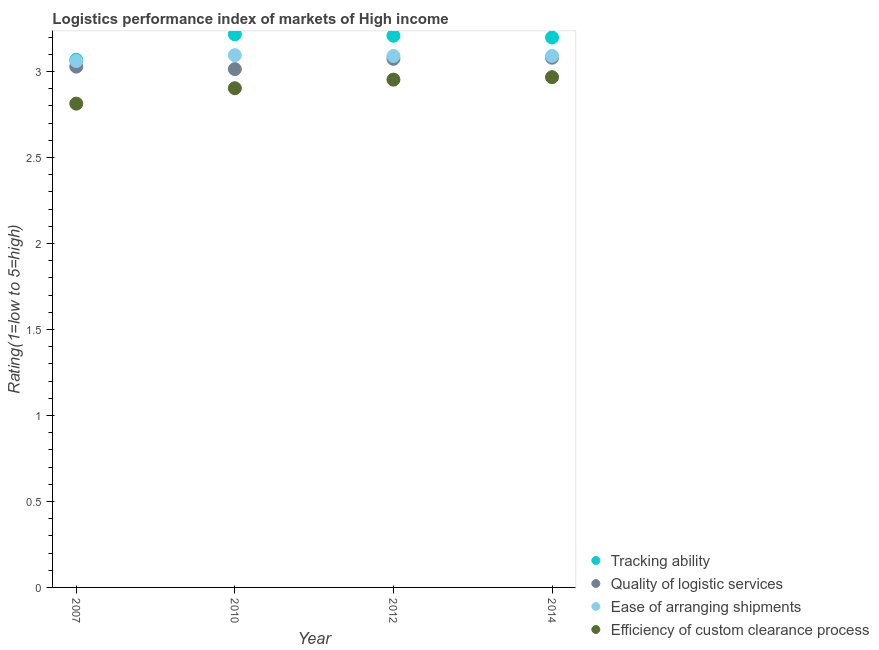How many different coloured dotlines are there?
Keep it short and to the point. 4. What is the lpi rating of efficiency of custom clearance process in 2007?
Ensure brevity in your answer.  2.81. Across all years, what is the maximum lpi rating of ease of arranging shipments?
Offer a very short reply. 3.1. Across all years, what is the minimum lpi rating of efficiency of custom clearance process?
Your answer should be very brief. 2.81. What is the total lpi rating of tracking ability in the graph?
Provide a succinct answer. 12.69. What is the difference between the lpi rating of tracking ability in 2007 and that in 2014?
Keep it short and to the point. -0.13. What is the difference between the lpi rating of ease of arranging shipments in 2007 and the lpi rating of tracking ability in 2014?
Provide a short and direct response. -0.14. What is the average lpi rating of quality of logistic services per year?
Ensure brevity in your answer.  3.05. In the year 2014, what is the difference between the lpi rating of ease of arranging shipments and lpi rating of efficiency of custom clearance process?
Offer a terse response. 0.12. What is the ratio of the lpi rating of tracking ability in 2007 to that in 2012?
Provide a succinct answer. 0.96. Is the lpi rating of ease of arranging shipments in 2010 less than that in 2014?
Your answer should be very brief. No. Is the difference between the lpi rating of efficiency of custom clearance process in 2007 and 2014 greater than the difference between the lpi rating of ease of arranging shipments in 2007 and 2014?
Your answer should be compact. No. What is the difference between the highest and the second highest lpi rating of quality of logistic services?
Give a very brief answer. 0.01. What is the difference between the highest and the lowest lpi rating of ease of arranging shipments?
Keep it short and to the point. 0.03. Is it the case that in every year, the sum of the lpi rating of tracking ability and lpi rating of efficiency of custom clearance process is greater than the sum of lpi rating of quality of logistic services and lpi rating of ease of arranging shipments?
Provide a short and direct response. No. Is the lpi rating of efficiency of custom clearance process strictly greater than the lpi rating of ease of arranging shipments over the years?
Make the answer very short. No. How many dotlines are there?
Provide a short and direct response. 4. Does the graph contain grids?
Give a very brief answer. No. What is the title of the graph?
Keep it short and to the point. Logistics performance index of markets of High income. What is the label or title of the X-axis?
Your answer should be very brief. Year. What is the label or title of the Y-axis?
Your response must be concise. Rating(1=low to 5=high). What is the Rating(1=low to 5=high) of Tracking ability in 2007?
Provide a short and direct response. 3.07. What is the Rating(1=low to 5=high) of Quality of logistic services in 2007?
Provide a short and direct response. 3.03. What is the Rating(1=low to 5=high) of Ease of arranging shipments in 2007?
Make the answer very short. 3.06. What is the Rating(1=low to 5=high) of Efficiency of custom clearance process in 2007?
Make the answer very short. 2.81. What is the Rating(1=low to 5=high) of Tracking ability in 2010?
Provide a succinct answer. 3.22. What is the Rating(1=low to 5=high) in Quality of logistic services in 2010?
Give a very brief answer. 3.01. What is the Rating(1=low to 5=high) in Ease of arranging shipments in 2010?
Give a very brief answer. 3.1. What is the Rating(1=low to 5=high) in Efficiency of custom clearance process in 2010?
Provide a short and direct response. 2.9. What is the Rating(1=low to 5=high) in Tracking ability in 2012?
Make the answer very short. 3.21. What is the Rating(1=low to 5=high) of Quality of logistic services in 2012?
Make the answer very short. 3.07. What is the Rating(1=low to 5=high) in Ease of arranging shipments in 2012?
Offer a very short reply. 3.09. What is the Rating(1=low to 5=high) in Efficiency of custom clearance process in 2012?
Provide a short and direct response. 2.95. What is the Rating(1=low to 5=high) in Tracking ability in 2014?
Keep it short and to the point. 3.2. What is the Rating(1=low to 5=high) in Quality of logistic services in 2014?
Make the answer very short. 3.08. What is the Rating(1=low to 5=high) in Ease of arranging shipments in 2014?
Keep it short and to the point. 3.09. What is the Rating(1=low to 5=high) of Efficiency of custom clearance process in 2014?
Offer a terse response. 2.97. Across all years, what is the maximum Rating(1=low to 5=high) of Tracking ability?
Your answer should be compact. 3.22. Across all years, what is the maximum Rating(1=low to 5=high) in Quality of logistic services?
Your answer should be compact. 3.08. Across all years, what is the maximum Rating(1=low to 5=high) of Ease of arranging shipments?
Provide a succinct answer. 3.1. Across all years, what is the maximum Rating(1=low to 5=high) in Efficiency of custom clearance process?
Offer a terse response. 2.97. Across all years, what is the minimum Rating(1=low to 5=high) in Tracking ability?
Provide a succinct answer. 3.07. Across all years, what is the minimum Rating(1=low to 5=high) in Quality of logistic services?
Offer a terse response. 3.01. Across all years, what is the minimum Rating(1=low to 5=high) of Ease of arranging shipments?
Make the answer very short. 3.06. Across all years, what is the minimum Rating(1=low to 5=high) of Efficiency of custom clearance process?
Provide a short and direct response. 2.81. What is the total Rating(1=low to 5=high) in Tracking ability in the graph?
Your response must be concise. 12.69. What is the total Rating(1=low to 5=high) of Quality of logistic services in the graph?
Give a very brief answer. 12.2. What is the total Rating(1=low to 5=high) in Ease of arranging shipments in the graph?
Offer a very short reply. 12.34. What is the total Rating(1=low to 5=high) of Efficiency of custom clearance process in the graph?
Your answer should be very brief. 11.64. What is the difference between the Rating(1=low to 5=high) in Tracking ability in 2007 and that in 2010?
Your response must be concise. -0.15. What is the difference between the Rating(1=low to 5=high) of Quality of logistic services in 2007 and that in 2010?
Offer a very short reply. 0.01. What is the difference between the Rating(1=low to 5=high) of Ease of arranging shipments in 2007 and that in 2010?
Your answer should be very brief. -0.03. What is the difference between the Rating(1=low to 5=high) in Efficiency of custom clearance process in 2007 and that in 2010?
Offer a very short reply. -0.09. What is the difference between the Rating(1=low to 5=high) of Tracking ability in 2007 and that in 2012?
Provide a succinct answer. -0.14. What is the difference between the Rating(1=low to 5=high) in Quality of logistic services in 2007 and that in 2012?
Give a very brief answer. -0.05. What is the difference between the Rating(1=low to 5=high) in Ease of arranging shipments in 2007 and that in 2012?
Ensure brevity in your answer.  -0.03. What is the difference between the Rating(1=low to 5=high) in Efficiency of custom clearance process in 2007 and that in 2012?
Provide a short and direct response. -0.14. What is the difference between the Rating(1=low to 5=high) in Tracking ability in 2007 and that in 2014?
Offer a very short reply. -0.13. What is the difference between the Rating(1=low to 5=high) of Quality of logistic services in 2007 and that in 2014?
Offer a terse response. -0.05. What is the difference between the Rating(1=low to 5=high) in Ease of arranging shipments in 2007 and that in 2014?
Offer a terse response. -0.03. What is the difference between the Rating(1=low to 5=high) in Efficiency of custom clearance process in 2007 and that in 2014?
Keep it short and to the point. -0.15. What is the difference between the Rating(1=low to 5=high) in Tracking ability in 2010 and that in 2012?
Your answer should be compact. 0.01. What is the difference between the Rating(1=low to 5=high) in Quality of logistic services in 2010 and that in 2012?
Keep it short and to the point. -0.06. What is the difference between the Rating(1=low to 5=high) of Ease of arranging shipments in 2010 and that in 2012?
Offer a terse response. 0. What is the difference between the Rating(1=low to 5=high) in Efficiency of custom clearance process in 2010 and that in 2012?
Your answer should be compact. -0.05. What is the difference between the Rating(1=low to 5=high) in Tracking ability in 2010 and that in 2014?
Keep it short and to the point. 0.02. What is the difference between the Rating(1=low to 5=high) of Quality of logistic services in 2010 and that in 2014?
Ensure brevity in your answer.  -0.07. What is the difference between the Rating(1=low to 5=high) of Ease of arranging shipments in 2010 and that in 2014?
Ensure brevity in your answer.  0. What is the difference between the Rating(1=low to 5=high) of Efficiency of custom clearance process in 2010 and that in 2014?
Make the answer very short. -0.06. What is the difference between the Rating(1=low to 5=high) in Tracking ability in 2012 and that in 2014?
Offer a terse response. 0.01. What is the difference between the Rating(1=low to 5=high) of Quality of logistic services in 2012 and that in 2014?
Offer a terse response. -0.01. What is the difference between the Rating(1=low to 5=high) in Ease of arranging shipments in 2012 and that in 2014?
Offer a very short reply. -0. What is the difference between the Rating(1=low to 5=high) of Efficiency of custom clearance process in 2012 and that in 2014?
Keep it short and to the point. -0.01. What is the difference between the Rating(1=low to 5=high) of Tracking ability in 2007 and the Rating(1=low to 5=high) of Quality of logistic services in 2010?
Provide a succinct answer. 0.05. What is the difference between the Rating(1=low to 5=high) in Tracking ability in 2007 and the Rating(1=low to 5=high) in Ease of arranging shipments in 2010?
Offer a very short reply. -0.03. What is the difference between the Rating(1=low to 5=high) in Tracking ability in 2007 and the Rating(1=low to 5=high) in Efficiency of custom clearance process in 2010?
Offer a terse response. 0.17. What is the difference between the Rating(1=low to 5=high) of Quality of logistic services in 2007 and the Rating(1=low to 5=high) of Ease of arranging shipments in 2010?
Provide a short and direct response. -0.07. What is the difference between the Rating(1=low to 5=high) of Quality of logistic services in 2007 and the Rating(1=low to 5=high) of Efficiency of custom clearance process in 2010?
Keep it short and to the point. 0.13. What is the difference between the Rating(1=low to 5=high) in Ease of arranging shipments in 2007 and the Rating(1=low to 5=high) in Efficiency of custom clearance process in 2010?
Provide a short and direct response. 0.16. What is the difference between the Rating(1=low to 5=high) in Tracking ability in 2007 and the Rating(1=low to 5=high) in Quality of logistic services in 2012?
Provide a succinct answer. -0.01. What is the difference between the Rating(1=low to 5=high) in Tracking ability in 2007 and the Rating(1=low to 5=high) in Ease of arranging shipments in 2012?
Make the answer very short. -0.02. What is the difference between the Rating(1=low to 5=high) in Tracking ability in 2007 and the Rating(1=low to 5=high) in Efficiency of custom clearance process in 2012?
Provide a succinct answer. 0.12. What is the difference between the Rating(1=low to 5=high) in Quality of logistic services in 2007 and the Rating(1=low to 5=high) in Ease of arranging shipments in 2012?
Provide a succinct answer. -0.06. What is the difference between the Rating(1=low to 5=high) in Quality of logistic services in 2007 and the Rating(1=low to 5=high) in Efficiency of custom clearance process in 2012?
Give a very brief answer. 0.08. What is the difference between the Rating(1=low to 5=high) in Ease of arranging shipments in 2007 and the Rating(1=low to 5=high) in Efficiency of custom clearance process in 2012?
Keep it short and to the point. 0.11. What is the difference between the Rating(1=low to 5=high) in Tracking ability in 2007 and the Rating(1=low to 5=high) in Quality of logistic services in 2014?
Offer a very short reply. -0.01. What is the difference between the Rating(1=low to 5=high) in Tracking ability in 2007 and the Rating(1=low to 5=high) in Ease of arranging shipments in 2014?
Keep it short and to the point. -0.02. What is the difference between the Rating(1=low to 5=high) in Tracking ability in 2007 and the Rating(1=low to 5=high) in Efficiency of custom clearance process in 2014?
Give a very brief answer. 0.1. What is the difference between the Rating(1=low to 5=high) of Quality of logistic services in 2007 and the Rating(1=low to 5=high) of Ease of arranging shipments in 2014?
Your answer should be very brief. -0.06. What is the difference between the Rating(1=low to 5=high) of Quality of logistic services in 2007 and the Rating(1=low to 5=high) of Efficiency of custom clearance process in 2014?
Your response must be concise. 0.06. What is the difference between the Rating(1=low to 5=high) of Ease of arranging shipments in 2007 and the Rating(1=low to 5=high) of Efficiency of custom clearance process in 2014?
Your answer should be very brief. 0.09. What is the difference between the Rating(1=low to 5=high) of Tracking ability in 2010 and the Rating(1=low to 5=high) of Quality of logistic services in 2012?
Keep it short and to the point. 0.14. What is the difference between the Rating(1=low to 5=high) of Tracking ability in 2010 and the Rating(1=low to 5=high) of Ease of arranging shipments in 2012?
Your answer should be compact. 0.13. What is the difference between the Rating(1=low to 5=high) of Tracking ability in 2010 and the Rating(1=low to 5=high) of Efficiency of custom clearance process in 2012?
Make the answer very short. 0.26. What is the difference between the Rating(1=low to 5=high) of Quality of logistic services in 2010 and the Rating(1=low to 5=high) of Ease of arranging shipments in 2012?
Offer a terse response. -0.08. What is the difference between the Rating(1=low to 5=high) of Quality of logistic services in 2010 and the Rating(1=low to 5=high) of Efficiency of custom clearance process in 2012?
Provide a succinct answer. 0.06. What is the difference between the Rating(1=low to 5=high) of Ease of arranging shipments in 2010 and the Rating(1=low to 5=high) of Efficiency of custom clearance process in 2012?
Keep it short and to the point. 0.14. What is the difference between the Rating(1=low to 5=high) of Tracking ability in 2010 and the Rating(1=low to 5=high) of Quality of logistic services in 2014?
Provide a succinct answer. 0.14. What is the difference between the Rating(1=low to 5=high) of Tracking ability in 2010 and the Rating(1=low to 5=high) of Ease of arranging shipments in 2014?
Ensure brevity in your answer.  0.13. What is the difference between the Rating(1=low to 5=high) of Tracking ability in 2010 and the Rating(1=low to 5=high) of Efficiency of custom clearance process in 2014?
Make the answer very short. 0.25. What is the difference between the Rating(1=low to 5=high) in Quality of logistic services in 2010 and the Rating(1=low to 5=high) in Ease of arranging shipments in 2014?
Provide a succinct answer. -0.08. What is the difference between the Rating(1=low to 5=high) of Quality of logistic services in 2010 and the Rating(1=low to 5=high) of Efficiency of custom clearance process in 2014?
Your response must be concise. 0.05. What is the difference between the Rating(1=low to 5=high) in Ease of arranging shipments in 2010 and the Rating(1=low to 5=high) in Efficiency of custom clearance process in 2014?
Offer a terse response. 0.13. What is the difference between the Rating(1=low to 5=high) in Tracking ability in 2012 and the Rating(1=low to 5=high) in Quality of logistic services in 2014?
Ensure brevity in your answer.  0.13. What is the difference between the Rating(1=low to 5=high) of Tracking ability in 2012 and the Rating(1=low to 5=high) of Ease of arranging shipments in 2014?
Offer a very short reply. 0.12. What is the difference between the Rating(1=low to 5=high) of Tracking ability in 2012 and the Rating(1=low to 5=high) of Efficiency of custom clearance process in 2014?
Make the answer very short. 0.24. What is the difference between the Rating(1=low to 5=high) of Quality of logistic services in 2012 and the Rating(1=low to 5=high) of Ease of arranging shipments in 2014?
Your answer should be very brief. -0.02. What is the difference between the Rating(1=low to 5=high) of Quality of logistic services in 2012 and the Rating(1=low to 5=high) of Efficiency of custom clearance process in 2014?
Offer a very short reply. 0.11. What is the difference between the Rating(1=low to 5=high) in Ease of arranging shipments in 2012 and the Rating(1=low to 5=high) in Efficiency of custom clearance process in 2014?
Offer a very short reply. 0.12. What is the average Rating(1=low to 5=high) in Tracking ability per year?
Offer a very short reply. 3.17. What is the average Rating(1=low to 5=high) in Quality of logistic services per year?
Make the answer very short. 3.05. What is the average Rating(1=low to 5=high) of Ease of arranging shipments per year?
Make the answer very short. 3.08. What is the average Rating(1=low to 5=high) in Efficiency of custom clearance process per year?
Your answer should be compact. 2.91. In the year 2007, what is the difference between the Rating(1=low to 5=high) in Tracking ability and Rating(1=low to 5=high) in Quality of logistic services?
Ensure brevity in your answer.  0.04. In the year 2007, what is the difference between the Rating(1=low to 5=high) in Tracking ability and Rating(1=low to 5=high) in Ease of arranging shipments?
Provide a short and direct response. 0.01. In the year 2007, what is the difference between the Rating(1=low to 5=high) in Tracking ability and Rating(1=low to 5=high) in Efficiency of custom clearance process?
Provide a short and direct response. 0.25. In the year 2007, what is the difference between the Rating(1=low to 5=high) of Quality of logistic services and Rating(1=low to 5=high) of Ease of arranging shipments?
Offer a terse response. -0.03. In the year 2007, what is the difference between the Rating(1=low to 5=high) of Quality of logistic services and Rating(1=low to 5=high) of Efficiency of custom clearance process?
Your answer should be compact. 0.22. In the year 2007, what is the difference between the Rating(1=low to 5=high) of Ease of arranging shipments and Rating(1=low to 5=high) of Efficiency of custom clearance process?
Provide a succinct answer. 0.25. In the year 2010, what is the difference between the Rating(1=low to 5=high) of Tracking ability and Rating(1=low to 5=high) of Quality of logistic services?
Provide a short and direct response. 0.2. In the year 2010, what is the difference between the Rating(1=low to 5=high) in Tracking ability and Rating(1=low to 5=high) in Ease of arranging shipments?
Provide a short and direct response. 0.12. In the year 2010, what is the difference between the Rating(1=low to 5=high) in Tracking ability and Rating(1=low to 5=high) in Efficiency of custom clearance process?
Offer a very short reply. 0.31. In the year 2010, what is the difference between the Rating(1=low to 5=high) of Quality of logistic services and Rating(1=low to 5=high) of Ease of arranging shipments?
Offer a terse response. -0.08. In the year 2010, what is the difference between the Rating(1=low to 5=high) in Ease of arranging shipments and Rating(1=low to 5=high) in Efficiency of custom clearance process?
Keep it short and to the point. 0.19. In the year 2012, what is the difference between the Rating(1=low to 5=high) of Tracking ability and Rating(1=low to 5=high) of Quality of logistic services?
Keep it short and to the point. 0.13. In the year 2012, what is the difference between the Rating(1=low to 5=high) in Tracking ability and Rating(1=low to 5=high) in Ease of arranging shipments?
Your answer should be compact. 0.12. In the year 2012, what is the difference between the Rating(1=low to 5=high) in Tracking ability and Rating(1=low to 5=high) in Efficiency of custom clearance process?
Your answer should be very brief. 0.26. In the year 2012, what is the difference between the Rating(1=low to 5=high) in Quality of logistic services and Rating(1=low to 5=high) in Ease of arranging shipments?
Keep it short and to the point. -0.02. In the year 2012, what is the difference between the Rating(1=low to 5=high) of Quality of logistic services and Rating(1=low to 5=high) of Efficiency of custom clearance process?
Offer a very short reply. 0.12. In the year 2012, what is the difference between the Rating(1=low to 5=high) of Ease of arranging shipments and Rating(1=low to 5=high) of Efficiency of custom clearance process?
Offer a very short reply. 0.14. In the year 2014, what is the difference between the Rating(1=low to 5=high) in Tracking ability and Rating(1=low to 5=high) in Quality of logistic services?
Offer a very short reply. 0.12. In the year 2014, what is the difference between the Rating(1=low to 5=high) of Tracking ability and Rating(1=low to 5=high) of Ease of arranging shipments?
Keep it short and to the point. 0.11. In the year 2014, what is the difference between the Rating(1=low to 5=high) in Tracking ability and Rating(1=low to 5=high) in Efficiency of custom clearance process?
Give a very brief answer. 0.23. In the year 2014, what is the difference between the Rating(1=low to 5=high) of Quality of logistic services and Rating(1=low to 5=high) of Ease of arranging shipments?
Offer a terse response. -0.01. In the year 2014, what is the difference between the Rating(1=low to 5=high) of Quality of logistic services and Rating(1=low to 5=high) of Efficiency of custom clearance process?
Ensure brevity in your answer.  0.11. In the year 2014, what is the difference between the Rating(1=low to 5=high) of Ease of arranging shipments and Rating(1=low to 5=high) of Efficiency of custom clearance process?
Ensure brevity in your answer.  0.12. What is the ratio of the Rating(1=low to 5=high) of Tracking ability in 2007 to that in 2010?
Provide a short and direct response. 0.95. What is the ratio of the Rating(1=low to 5=high) in Ease of arranging shipments in 2007 to that in 2010?
Make the answer very short. 0.99. What is the ratio of the Rating(1=low to 5=high) in Efficiency of custom clearance process in 2007 to that in 2010?
Make the answer very short. 0.97. What is the ratio of the Rating(1=low to 5=high) in Tracking ability in 2007 to that in 2012?
Offer a very short reply. 0.96. What is the ratio of the Rating(1=low to 5=high) in Quality of logistic services in 2007 to that in 2012?
Your response must be concise. 0.99. What is the ratio of the Rating(1=low to 5=high) of Ease of arranging shipments in 2007 to that in 2012?
Provide a succinct answer. 0.99. What is the ratio of the Rating(1=low to 5=high) in Efficiency of custom clearance process in 2007 to that in 2012?
Ensure brevity in your answer.  0.95. What is the ratio of the Rating(1=low to 5=high) of Tracking ability in 2007 to that in 2014?
Make the answer very short. 0.96. What is the ratio of the Rating(1=low to 5=high) in Quality of logistic services in 2007 to that in 2014?
Offer a very short reply. 0.98. What is the ratio of the Rating(1=low to 5=high) in Ease of arranging shipments in 2007 to that in 2014?
Your answer should be compact. 0.99. What is the ratio of the Rating(1=low to 5=high) in Efficiency of custom clearance process in 2007 to that in 2014?
Provide a succinct answer. 0.95. What is the ratio of the Rating(1=low to 5=high) in Quality of logistic services in 2010 to that in 2012?
Provide a succinct answer. 0.98. What is the ratio of the Rating(1=low to 5=high) in Ease of arranging shipments in 2010 to that in 2012?
Ensure brevity in your answer.  1. What is the ratio of the Rating(1=low to 5=high) in Efficiency of custom clearance process in 2010 to that in 2012?
Provide a short and direct response. 0.98. What is the ratio of the Rating(1=low to 5=high) of Tracking ability in 2010 to that in 2014?
Offer a terse response. 1.01. What is the ratio of the Rating(1=low to 5=high) in Quality of logistic services in 2010 to that in 2014?
Ensure brevity in your answer.  0.98. What is the ratio of the Rating(1=low to 5=high) in Efficiency of custom clearance process in 2010 to that in 2014?
Provide a short and direct response. 0.98. What is the difference between the highest and the second highest Rating(1=low to 5=high) of Tracking ability?
Keep it short and to the point. 0.01. What is the difference between the highest and the second highest Rating(1=low to 5=high) of Quality of logistic services?
Your answer should be compact. 0.01. What is the difference between the highest and the second highest Rating(1=low to 5=high) in Ease of arranging shipments?
Your answer should be compact. 0. What is the difference between the highest and the second highest Rating(1=low to 5=high) of Efficiency of custom clearance process?
Keep it short and to the point. 0.01. What is the difference between the highest and the lowest Rating(1=low to 5=high) of Tracking ability?
Provide a short and direct response. 0.15. What is the difference between the highest and the lowest Rating(1=low to 5=high) of Quality of logistic services?
Ensure brevity in your answer.  0.07. What is the difference between the highest and the lowest Rating(1=low to 5=high) in Ease of arranging shipments?
Provide a short and direct response. 0.03. What is the difference between the highest and the lowest Rating(1=low to 5=high) in Efficiency of custom clearance process?
Keep it short and to the point. 0.15. 